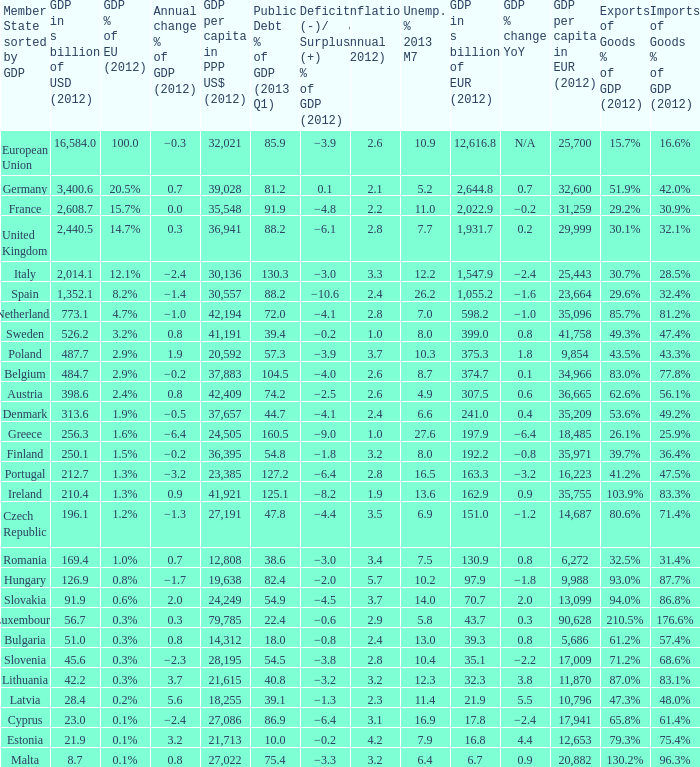What is the deficit/surplus % of the 2012 GDP of the country with a GDP in billions of USD in 2012 less than 1,352.1, a GDP per capita in PPP US dollars in 2012 greater than 21,615, public debt % of GDP in the 2013 Q1 less than 75.4, and an inflation % annual in 2012 of 2.9? −0.6. 